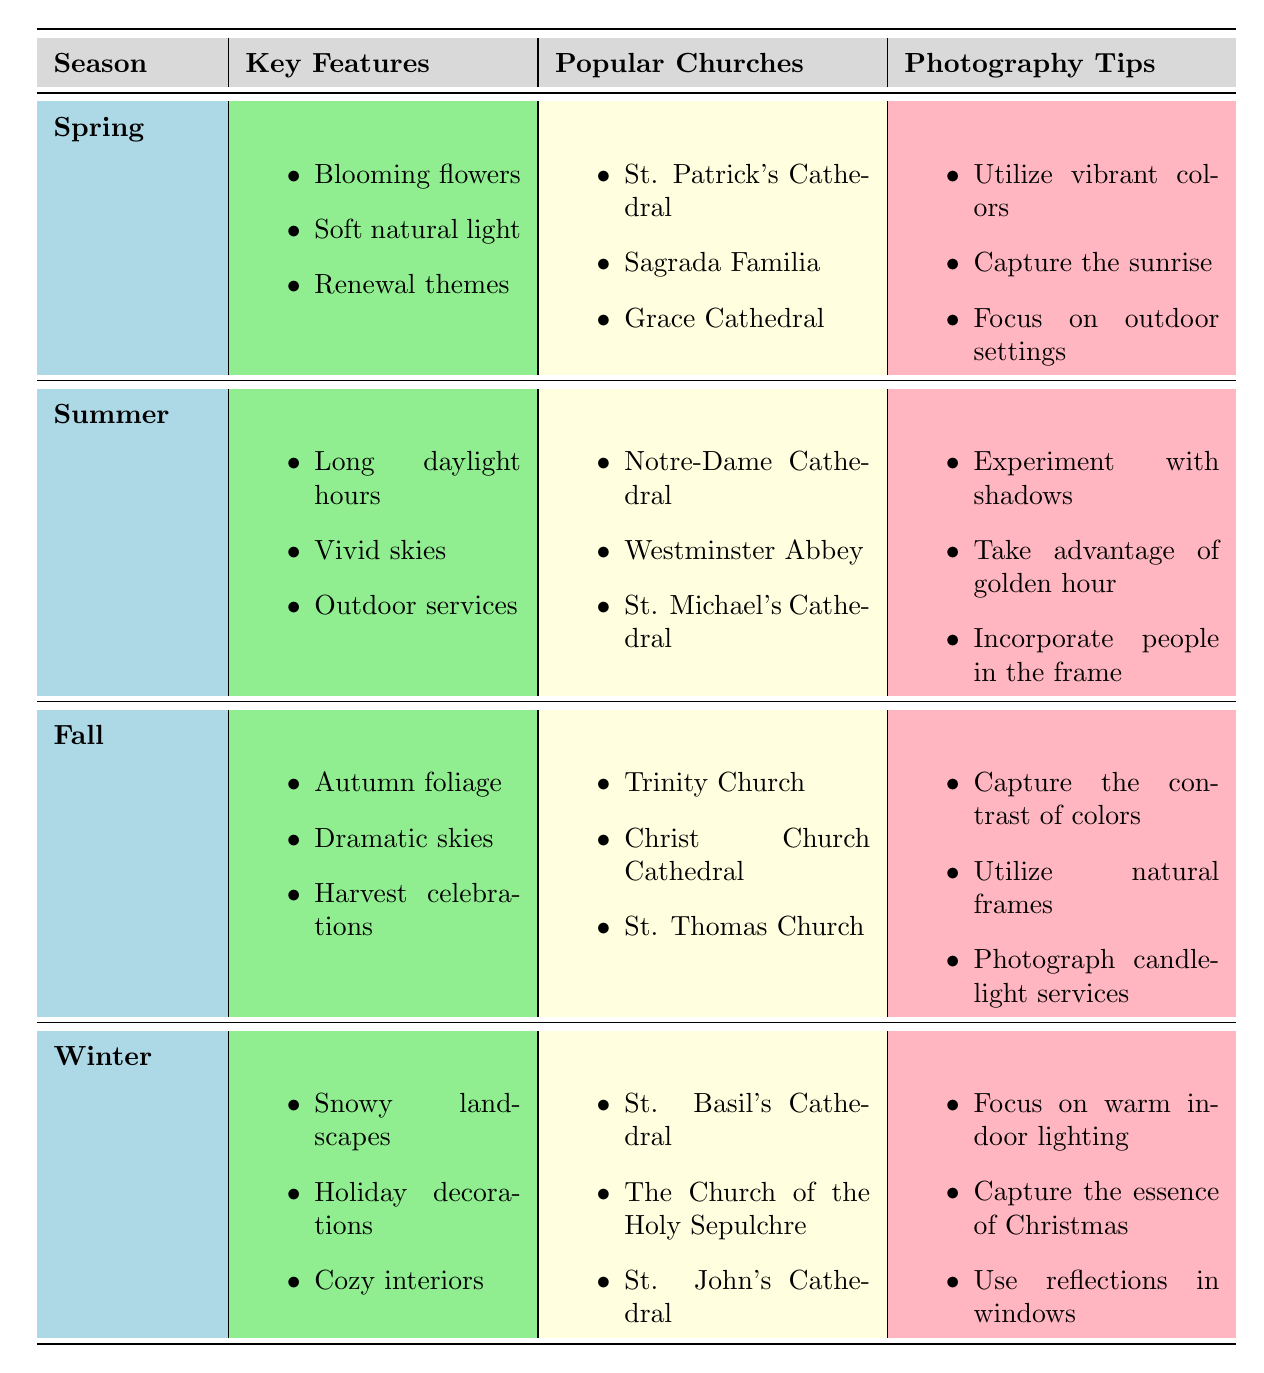What are the key features of Fall for church photography? The table lists the key features of Fall, which are "Autumn foliage," "Dramatic skies," and "Harvest celebrations."
Answer: Autumn foliage, Dramatic skies, Harvest celebrations Which church is popular in Winter photography? According to the table, St. Basil's Cathedral, The Church of the Holy Sepulchre, and St. John's Cathedral are mentioned as popular churches for Winter photography.
Answer: St. Basil's Cathedral, The Church of the Holy Sepulchre, St. John's Cathedral In which season can you find "Blooming flowers"? "Blooming flowers" is a key feature mentioned only in the Spring season according to the table.
Answer: Spring How many photography tips are listed for Summer? For Summer, three photography tips are listed: "Experiment with shadows," "Take advantage of golden hour," and "Incorporate people in the frame."
Answer: 3 Which season has the key feature of "Cozy interiors"? The key feature "Cozy interiors" is associated with Winter photography, as shown in the table.
Answer: Winter Is "Capture the essence of Christmas" a photography tip for Spring? The table lists "Capture the essence of Christmas" as a photography tip for Winter, indicating it is not associated with Spring.
Answer: No What is the difference in key features between Spring and Fall? Spring features "Blooming flowers," "Soft natural light," and "Renewal themes," while Fall features "Autumn foliage," "Dramatic skies," and "Harvest celebrations." The difference is that Spring emphasizes renewal and flowers, while Fall focuses on autumn colors and harvest.
Answer: Spring emphasizes flowers and renewal; Fall focuses on autumn and harvest Which season has the most vibrant skies among its key features? The table associates "Vivid skies" with Summer as one of its key features, suggesting it is the season with the most vibrant skies.
Answer: Summer If you want to focus on outdoor settings, in which season should you photograph? The photography tips for Spring include "Focus on outdoor settings," indicating that Spring is the best season to emphasize outdoor photography.
Answer: Spring How many popular churches are listed for Fall? The table states that three churches are popular for Fall photography: Trinity Church, Christ Church Cathedral, and St. Thomas Church.
Answer: 3 